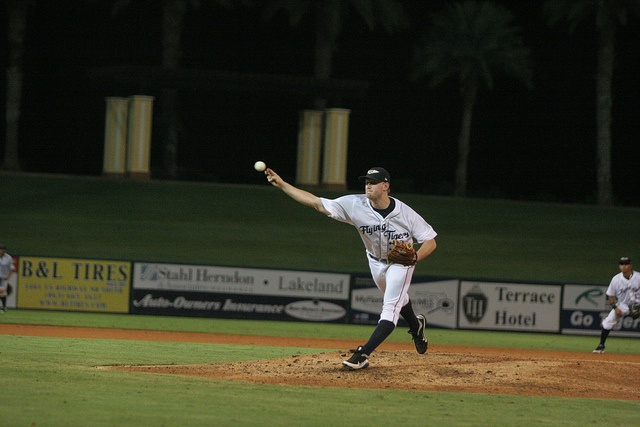Describe the objects in this image and their specific colors. I can see people in black, lavender, darkgray, and gray tones, people in black, darkgray, gray, and olive tones, baseball glove in black, maroon, and gray tones, people in black, gray, and maroon tones, and baseball glove in black, gray, and darkgreen tones in this image. 